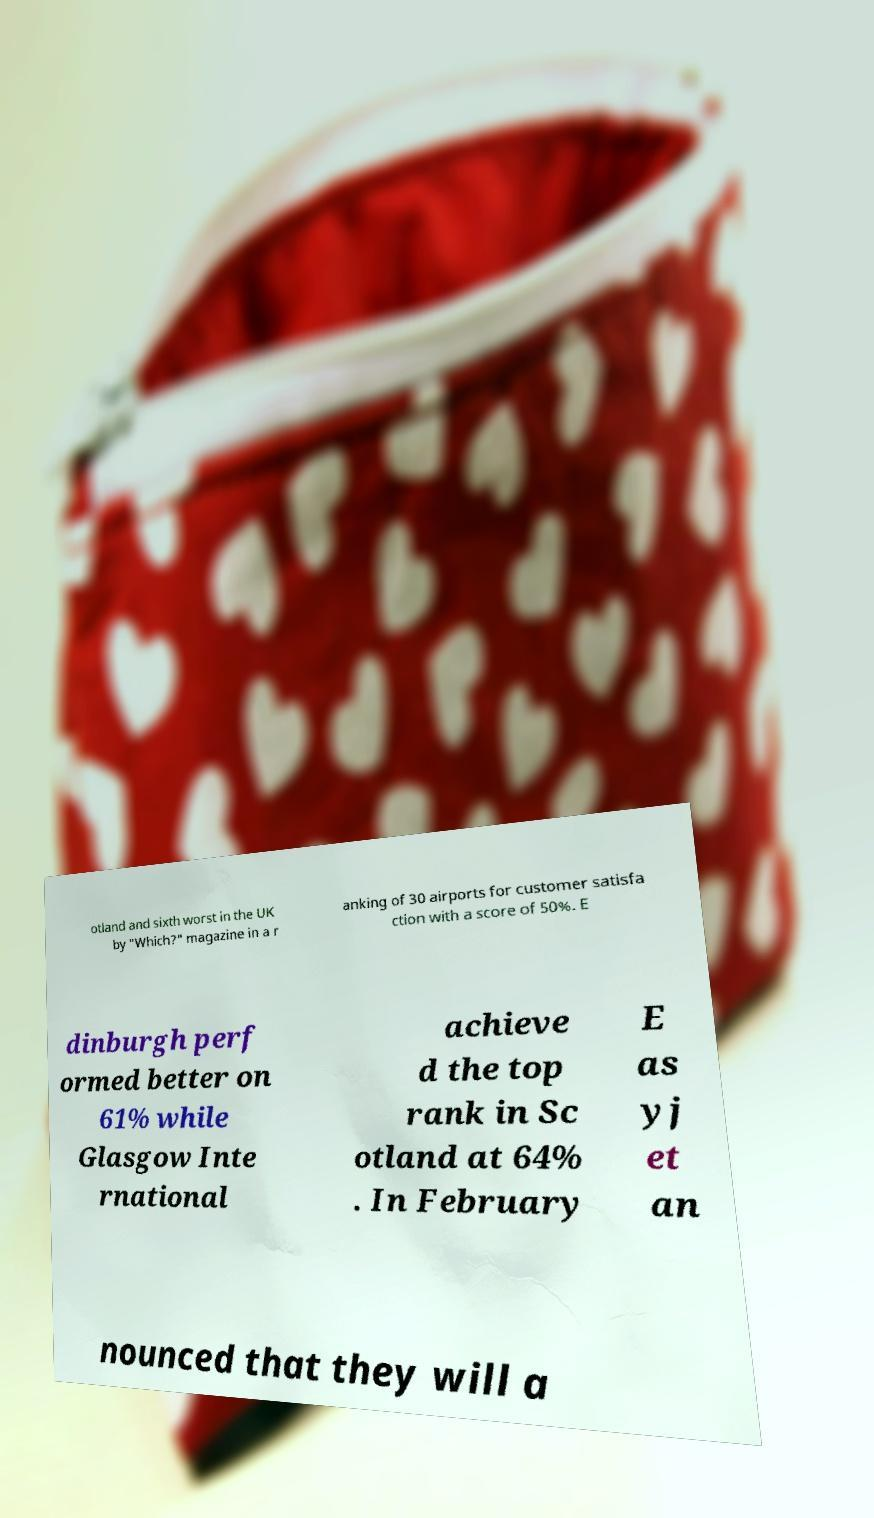What messages or text are displayed in this image? I need them in a readable, typed format. otland and sixth worst in the UK by "Which?" magazine in a r anking of 30 airports for customer satisfa ction with a score of 50%. E dinburgh perf ormed better on 61% while Glasgow Inte rnational achieve d the top rank in Sc otland at 64% . In February E as yj et an nounced that they will a 